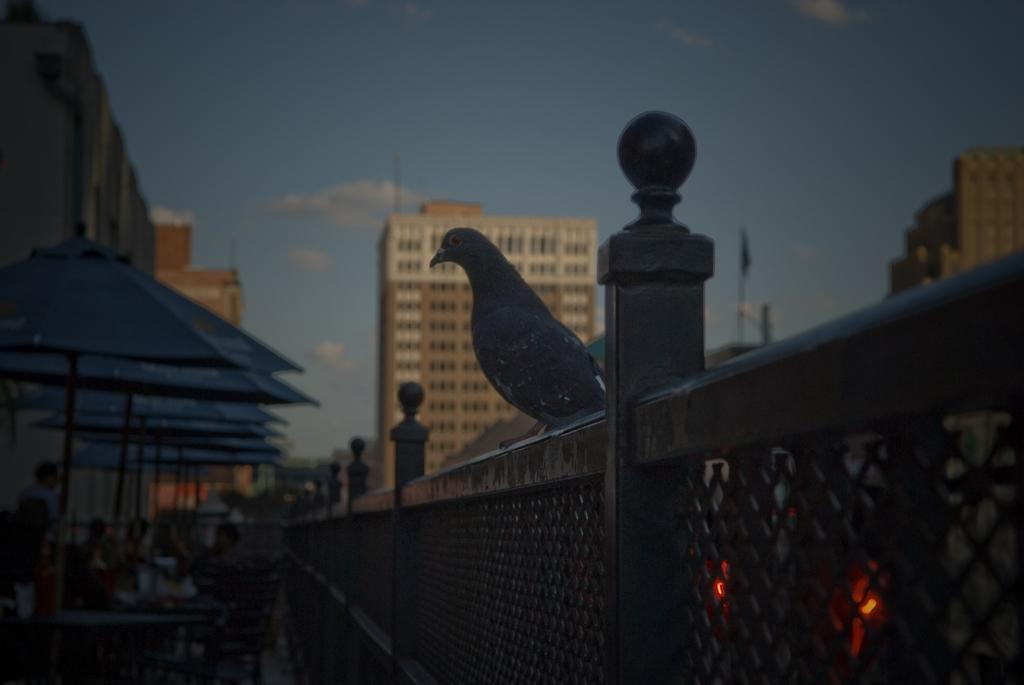What is located in the center of the image? There are buildings and a bird in the center of the image. What can be seen on the left side of the image? There are umbrellas on the left side of the image. How many geese are present in the image? There are no geese present in the image. What type of shoes can be seen on the bird in the image? There are no shoes visible in the image, as it features a bird and not a person or animal wearing shoes. 